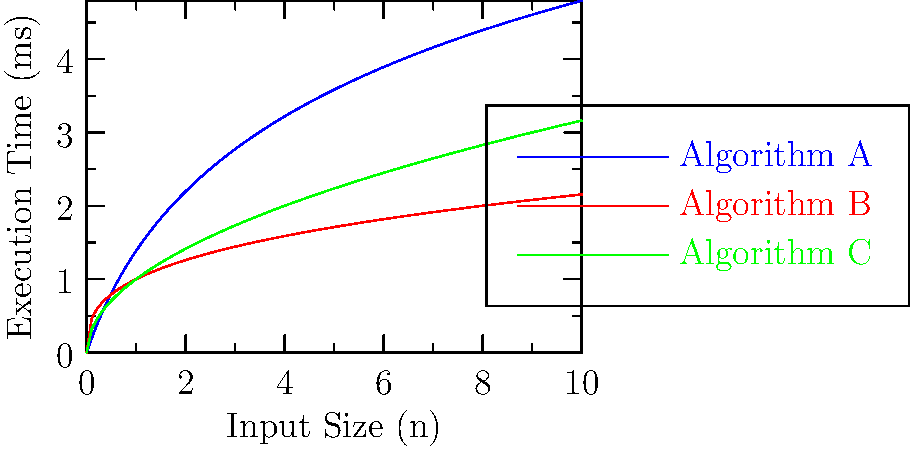Based on the performance graph comparing three mobile app algorithms (A, B, and C), which algorithm would you recommend for a professional requiring the most efficient solution for large input sizes? To determine the most efficient algorithm for large input sizes, we need to analyze the growth rate of each algorithm's execution time as the input size increases. Let's break it down step-by-step:

1. Identify the functions:
   - Algorithm A (blue): Appears to be logarithmic, $f(n) = c \log(n)$
   - Algorithm B (red): Appears to be cube root, $f(n) = n^{1/3}$
   - Algorithm C (green): Appears to be square root, $f(n) = \sqrt{n}$

2. Compare growth rates for large n:
   $\log(n) < n^{1/3} < \sqrt{n}$

3. Analyze asymptotic behavior:
   As n approaches infinity, the logarithmic function (Algorithm A) grows the slowest, meaning it will have the lowest execution time for large input sizes.

4. Consider practical implications:
   For a professional requiring the most efficient solution, the algorithm with the lowest execution time for large inputs is ideal, as it will scale better with increasing data sizes.

Therefore, Algorithm A (blue line) demonstrates the best performance for large input sizes, as its execution time grows logarithmically, which is slower than the cube root (Algorithm B) and square root (Algorithm C) growth rates.
Answer: Algorithm A 